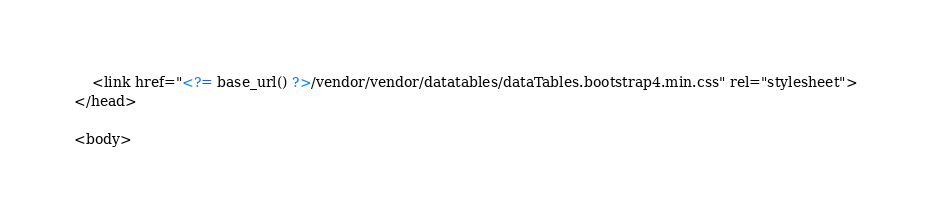Convert code to text. <code><loc_0><loc_0><loc_500><loc_500><_PHP_>    <link href="<?= base_url() ?>/vendor/vendor/datatables/dataTables.bootstrap4.min.css" rel="stylesheet">
</head>

<body></code> 